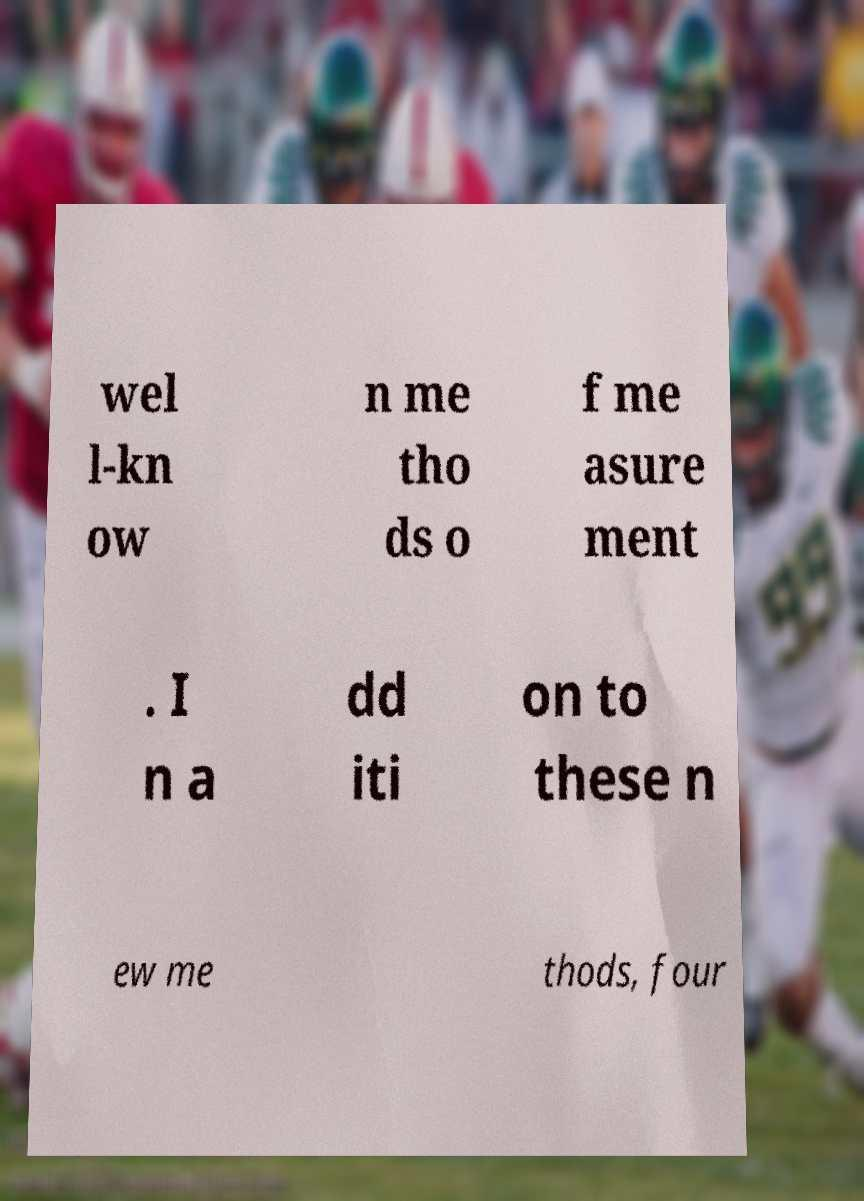Can you read and provide the text displayed in the image?This photo seems to have some interesting text. Can you extract and type it out for me? wel l-kn ow n me tho ds o f me asure ment . I n a dd iti on to these n ew me thods, four 